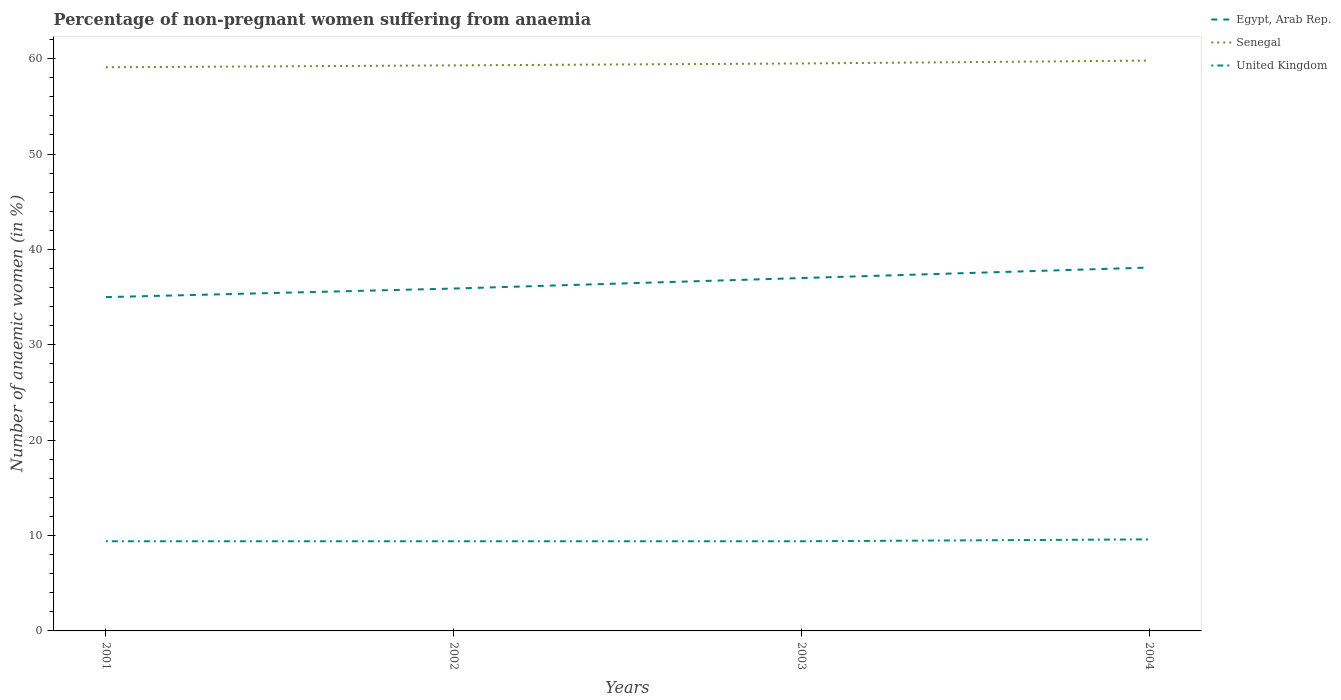Is the number of lines equal to the number of legend labels?
Your answer should be very brief. Yes. Across all years, what is the maximum percentage of non-pregnant women suffering from anaemia in Senegal?
Provide a succinct answer. 59.1. In which year was the percentage of non-pregnant women suffering from anaemia in Senegal maximum?
Provide a succinct answer. 2001. What is the total percentage of non-pregnant women suffering from anaemia in Egypt, Arab Rep. in the graph?
Ensure brevity in your answer.  -1.1. What is the difference between the highest and the second highest percentage of non-pregnant women suffering from anaemia in Egypt, Arab Rep.?
Keep it short and to the point. 3.1. What is the difference between the highest and the lowest percentage of non-pregnant women suffering from anaemia in Senegal?
Offer a very short reply. 2. What is the difference between two consecutive major ticks on the Y-axis?
Give a very brief answer. 10. How many legend labels are there?
Offer a very short reply. 3. How are the legend labels stacked?
Provide a short and direct response. Vertical. What is the title of the graph?
Offer a terse response. Percentage of non-pregnant women suffering from anaemia. What is the label or title of the Y-axis?
Give a very brief answer. Number of anaemic women (in %). What is the Number of anaemic women (in %) of Senegal in 2001?
Give a very brief answer. 59.1. What is the Number of anaemic women (in %) of Egypt, Arab Rep. in 2002?
Ensure brevity in your answer.  35.9. What is the Number of anaemic women (in %) of Senegal in 2002?
Provide a short and direct response. 59.3. What is the Number of anaemic women (in %) in United Kingdom in 2002?
Give a very brief answer. 9.4. What is the Number of anaemic women (in %) of Senegal in 2003?
Your answer should be very brief. 59.5. What is the Number of anaemic women (in %) in United Kingdom in 2003?
Make the answer very short. 9.4. What is the Number of anaemic women (in %) in Egypt, Arab Rep. in 2004?
Make the answer very short. 38.1. What is the Number of anaemic women (in %) of Senegal in 2004?
Make the answer very short. 59.8. What is the Number of anaemic women (in %) in United Kingdom in 2004?
Ensure brevity in your answer.  9.6. Across all years, what is the maximum Number of anaemic women (in %) of Egypt, Arab Rep.?
Your answer should be compact. 38.1. Across all years, what is the maximum Number of anaemic women (in %) in Senegal?
Your response must be concise. 59.8. Across all years, what is the minimum Number of anaemic women (in %) of Egypt, Arab Rep.?
Keep it short and to the point. 35. Across all years, what is the minimum Number of anaemic women (in %) of Senegal?
Provide a short and direct response. 59.1. What is the total Number of anaemic women (in %) in Egypt, Arab Rep. in the graph?
Ensure brevity in your answer.  146. What is the total Number of anaemic women (in %) of Senegal in the graph?
Offer a terse response. 237.7. What is the total Number of anaemic women (in %) of United Kingdom in the graph?
Provide a short and direct response. 37.8. What is the difference between the Number of anaemic women (in %) in Egypt, Arab Rep. in 2001 and that in 2002?
Your answer should be very brief. -0.9. What is the difference between the Number of anaemic women (in %) of Senegal in 2001 and that in 2002?
Provide a short and direct response. -0.2. What is the difference between the Number of anaemic women (in %) of Senegal in 2001 and that in 2003?
Your response must be concise. -0.4. What is the difference between the Number of anaemic women (in %) in United Kingdom in 2001 and that in 2003?
Keep it short and to the point. 0. What is the difference between the Number of anaemic women (in %) in Senegal in 2001 and that in 2004?
Provide a short and direct response. -0.7. What is the difference between the Number of anaemic women (in %) in United Kingdom in 2002 and that in 2003?
Your answer should be compact. 0. What is the difference between the Number of anaemic women (in %) of Egypt, Arab Rep. in 2002 and that in 2004?
Keep it short and to the point. -2.2. What is the difference between the Number of anaemic women (in %) of United Kingdom in 2002 and that in 2004?
Provide a short and direct response. -0.2. What is the difference between the Number of anaemic women (in %) of Egypt, Arab Rep. in 2003 and that in 2004?
Offer a terse response. -1.1. What is the difference between the Number of anaemic women (in %) in Egypt, Arab Rep. in 2001 and the Number of anaemic women (in %) in Senegal in 2002?
Your answer should be compact. -24.3. What is the difference between the Number of anaemic women (in %) in Egypt, Arab Rep. in 2001 and the Number of anaemic women (in %) in United Kingdom in 2002?
Provide a succinct answer. 25.6. What is the difference between the Number of anaemic women (in %) of Senegal in 2001 and the Number of anaemic women (in %) of United Kingdom in 2002?
Offer a terse response. 49.7. What is the difference between the Number of anaemic women (in %) of Egypt, Arab Rep. in 2001 and the Number of anaemic women (in %) of Senegal in 2003?
Offer a terse response. -24.5. What is the difference between the Number of anaemic women (in %) of Egypt, Arab Rep. in 2001 and the Number of anaemic women (in %) of United Kingdom in 2003?
Keep it short and to the point. 25.6. What is the difference between the Number of anaemic women (in %) in Senegal in 2001 and the Number of anaemic women (in %) in United Kingdom in 2003?
Your answer should be very brief. 49.7. What is the difference between the Number of anaemic women (in %) in Egypt, Arab Rep. in 2001 and the Number of anaemic women (in %) in Senegal in 2004?
Provide a succinct answer. -24.8. What is the difference between the Number of anaemic women (in %) in Egypt, Arab Rep. in 2001 and the Number of anaemic women (in %) in United Kingdom in 2004?
Ensure brevity in your answer.  25.4. What is the difference between the Number of anaemic women (in %) in Senegal in 2001 and the Number of anaemic women (in %) in United Kingdom in 2004?
Make the answer very short. 49.5. What is the difference between the Number of anaemic women (in %) in Egypt, Arab Rep. in 2002 and the Number of anaemic women (in %) in Senegal in 2003?
Your response must be concise. -23.6. What is the difference between the Number of anaemic women (in %) of Senegal in 2002 and the Number of anaemic women (in %) of United Kingdom in 2003?
Provide a short and direct response. 49.9. What is the difference between the Number of anaemic women (in %) of Egypt, Arab Rep. in 2002 and the Number of anaemic women (in %) of Senegal in 2004?
Offer a terse response. -23.9. What is the difference between the Number of anaemic women (in %) of Egypt, Arab Rep. in 2002 and the Number of anaemic women (in %) of United Kingdom in 2004?
Your answer should be compact. 26.3. What is the difference between the Number of anaemic women (in %) in Senegal in 2002 and the Number of anaemic women (in %) in United Kingdom in 2004?
Keep it short and to the point. 49.7. What is the difference between the Number of anaemic women (in %) in Egypt, Arab Rep. in 2003 and the Number of anaemic women (in %) in Senegal in 2004?
Provide a short and direct response. -22.8. What is the difference between the Number of anaemic women (in %) of Egypt, Arab Rep. in 2003 and the Number of anaemic women (in %) of United Kingdom in 2004?
Offer a very short reply. 27.4. What is the difference between the Number of anaemic women (in %) of Senegal in 2003 and the Number of anaemic women (in %) of United Kingdom in 2004?
Offer a terse response. 49.9. What is the average Number of anaemic women (in %) of Egypt, Arab Rep. per year?
Offer a very short reply. 36.5. What is the average Number of anaemic women (in %) in Senegal per year?
Offer a very short reply. 59.42. What is the average Number of anaemic women (in %) in United Kingdom per year?
Give a very brief answer. 9.45. In the year 2001, what is the difference between the Number of anaemic women (in %) of Egypt, Arab Rep. and Number of anaemic women (in %) of Senegal?
Provide a short and direct response. -24.1. In the year 2001, what is the difference between the Number of anaemic women (in %) in Egypt, Arab Rep. and Number of anaemic women (in %) in United Kingdom?
Provide a succinct answer. 25.6. In the year 2001, what is the difference between the Number of anaemic women (in %) in Senegal and Number of anaemic women (in %) in United Kingdom?
Keep it short and to the point. 49.7. In the year 2002, what is the difference between the Number of anaemic women (in %) of Egypt, Arab Rep. and Number of anaemic women (in %) of Senegal?
Offer a terse response. -23.4. In the year 2002, what is the difference between the Number of anaemic women (in %) in Senegal and Number of anaemic women (in %) in United Kingdom?
Your answer should be very brief. 49.9. In the year 2003, what is the difference between the Number of anaemic women (in %) of Egypt, Arab Rep. and Number of anaemic women (in %) of Senegal?
Your response must be concise. -22.5. In the year 2003, what is the difference between the Number of anaemic women (in %) of Egypt, Arab Rep. and Number of anaemic women (in %) of United Kingdom?
Your answer should be very brief. 27.6. In the year 2003, what is the difference between the Number of anaemic women (in %) in Senegal and Number of anaemic women (in %) in United Kingdom?
Ensure brevity in your answer.  50.1. In the year 2004, what is the difference between the Number of anaemic women (in %) of Egypt, Arab Rep. and Number of anaemic women (in %) of Senegal?
Offer a very short reply. -21.7. In the year 2004, what is the difference between the Number of anaemic women (in %) in Senegal and Number of anaemic women (in %) in United Kingdom?
Offer a terse response. 50.2. What is the ratio of the Number of anaemic women (in %) of Egypt, Arab Rep. in 2001 to that in 2002?
Offer a terse response. 0.97. What is the ratio of the Number of anaemic women (in %) in United Kingdom in 2001 to that in 2002?
Keep it short and to the point. 1. What is the ratio of the Number of anaemic women (in %) in Egypt, Arab Rep. in 2001 to that in 2003?
Offer a very short reply. 0.95. What is the ratio of the Number of anaemic women (in %) in Senegal in 2001 to that in 2003?
Ensure brevity in your answer.  0.99. What is the ratio of the Number of anaemic women (in %) in United Kingdom in 2001 to that in 2003?
Your answer should be compact. 1. What is the ratio of the Number of anaemic women (in %) of Egypt, Arab Rep. in 2001 to that in 2004?
Offer a terse response. 0.92. What is the ratio of the Number of anaemic women (in %) of Senegal in 2001 to that in 2004?
Ensure brevity in your answer.  0.99. What is the ratio of the Number of anaemic women (in %) of United Kingdom in 2001 to that in 2004?
Keep it short and to the point. 0.98. What is the ratio of the Number of anaemic women (in %) in Egypt, Arab Rep. in 2002 to that in 2003?
Your answer should be compact. 0.97. What is the ratio of the Number of anaemic women (in %) of Egypt, Arab Rep. in 2002 to that in 2004?
Offer a terse response. 0.94. What is the ratio of the Number of anaemic women (in %) of Senegal in 2002 to that in 2004?
Your answer should be very brief. 0.99. What is the ratio of the Number of anaemic women (in %) of United Kingdom in 2002 to that in 2004?
Provide a short and direct response. 0.98. What is the ratio of the Number of anaemic women (in %) of Egypt, Arab Rep. in 2003 to that in 2004?
Your answer should be compact. 0.97. What is the ratio of the Number of anaemic women (in %) in United Kingdom in 2003 to that in 2004?
Your answer should be very brief. 0.98. What is the difference between the highest and the second highest Number of anaemic women (in %) of Egypt, Arab Rep.?
Your answer should be compact. 1.1. What is the difference between the highest and the lowest Number of anaemic women (in %) of Egypt, Arab Rep.?
Provide a succinct answer. 3.1. What is the difference between the highest and the lowest Number of anaemic women (in %) of United Kingdom?
Provide a short and direct response. 0.2. 